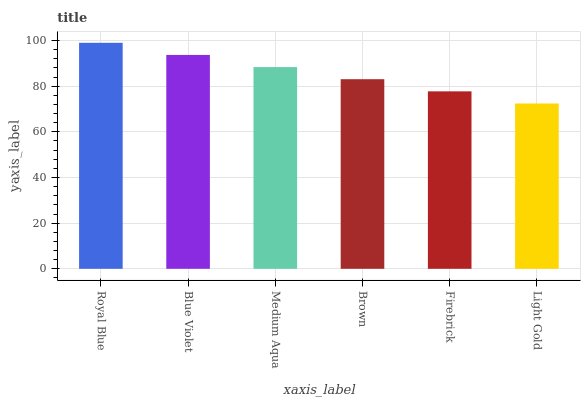Is Light Gold the minimum?
Answer yes or no. Yes. Is Royal Blue the maximum?
Answer yes or no. Yes. Is Blue Violet the minimum?
Answer yes or no. No. Is Blue Violet the maximum?
Answer yes or no. No. Is Royal Blue greater than Blue Violet?
Answer yes or no. Yes. Is Blue Violet less than Royal Blue?
Answer yes or no. Yes. Is Blue Violet greater than Royal Blue?
Answer yes or no. No. Is Royal Blue less than Blue Violet?
Answer yes or no. No. Is Medium Aqua the high median?
Answer yes or no. Yes. Is Brown the low median?
Answer yes or no. Yes. Is Blue Violet the high median?
Answer yes or no. No. Is Royal Blue the low median?
Answer yes or no. No. 